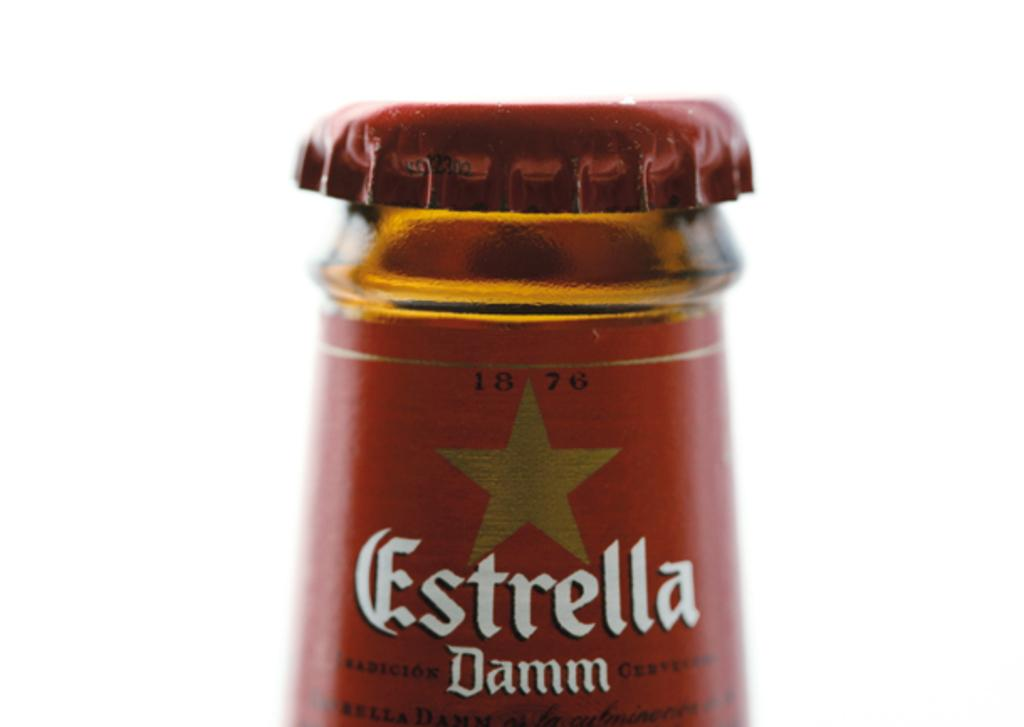Provide a one-sentence caption for the provided image. The top of a bottle of a drink called Estrella Damm. 